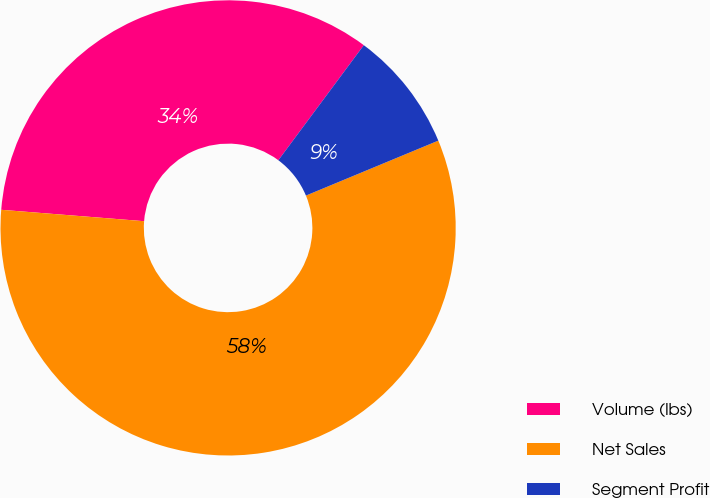Convert chart. <chart><loc_0><loc_0><loc_500><loc_500><pie_chart><fcel>Volume (lbs)<fcel>Net Sales<fcel>Segment Profit<nl><fcel>33.9%<fcel>57.53%<fcel>8.57%<nl></chart> 